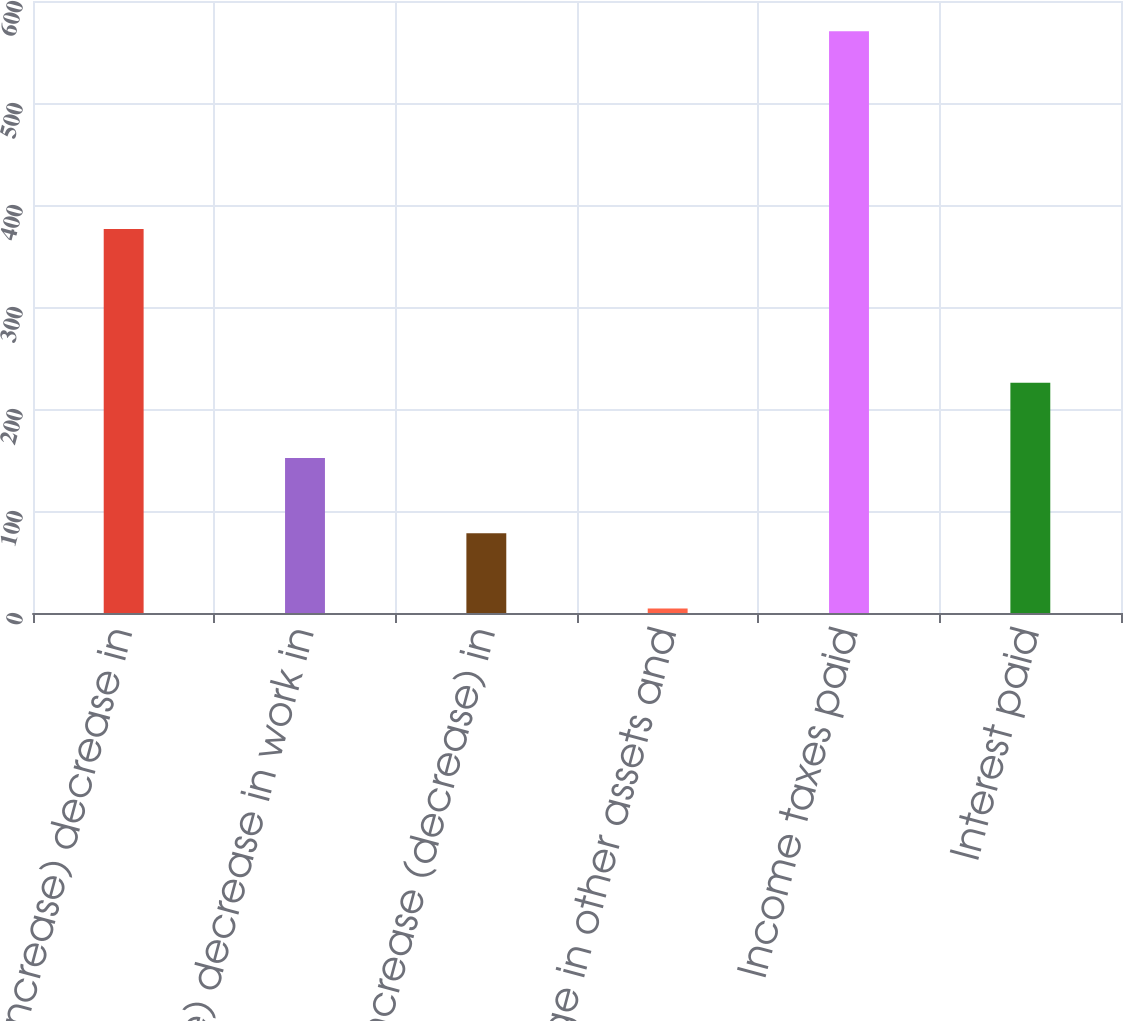<chart> <loc_0><loc_0><loc_500><loc_500><bar_chart><fcel>(Increase) decrease in<fcel>(Increase) decrease in work in<fcel>Increase (decrease) in<fcel>Change in other assets and<fcel>Income taxes paid<fcel>Interest paid<nl><fcel>376.5<fcel>151.98<fcel>78.24<fcel>4.5<fcel>570.4<fcel>225.72<nl></chart> 